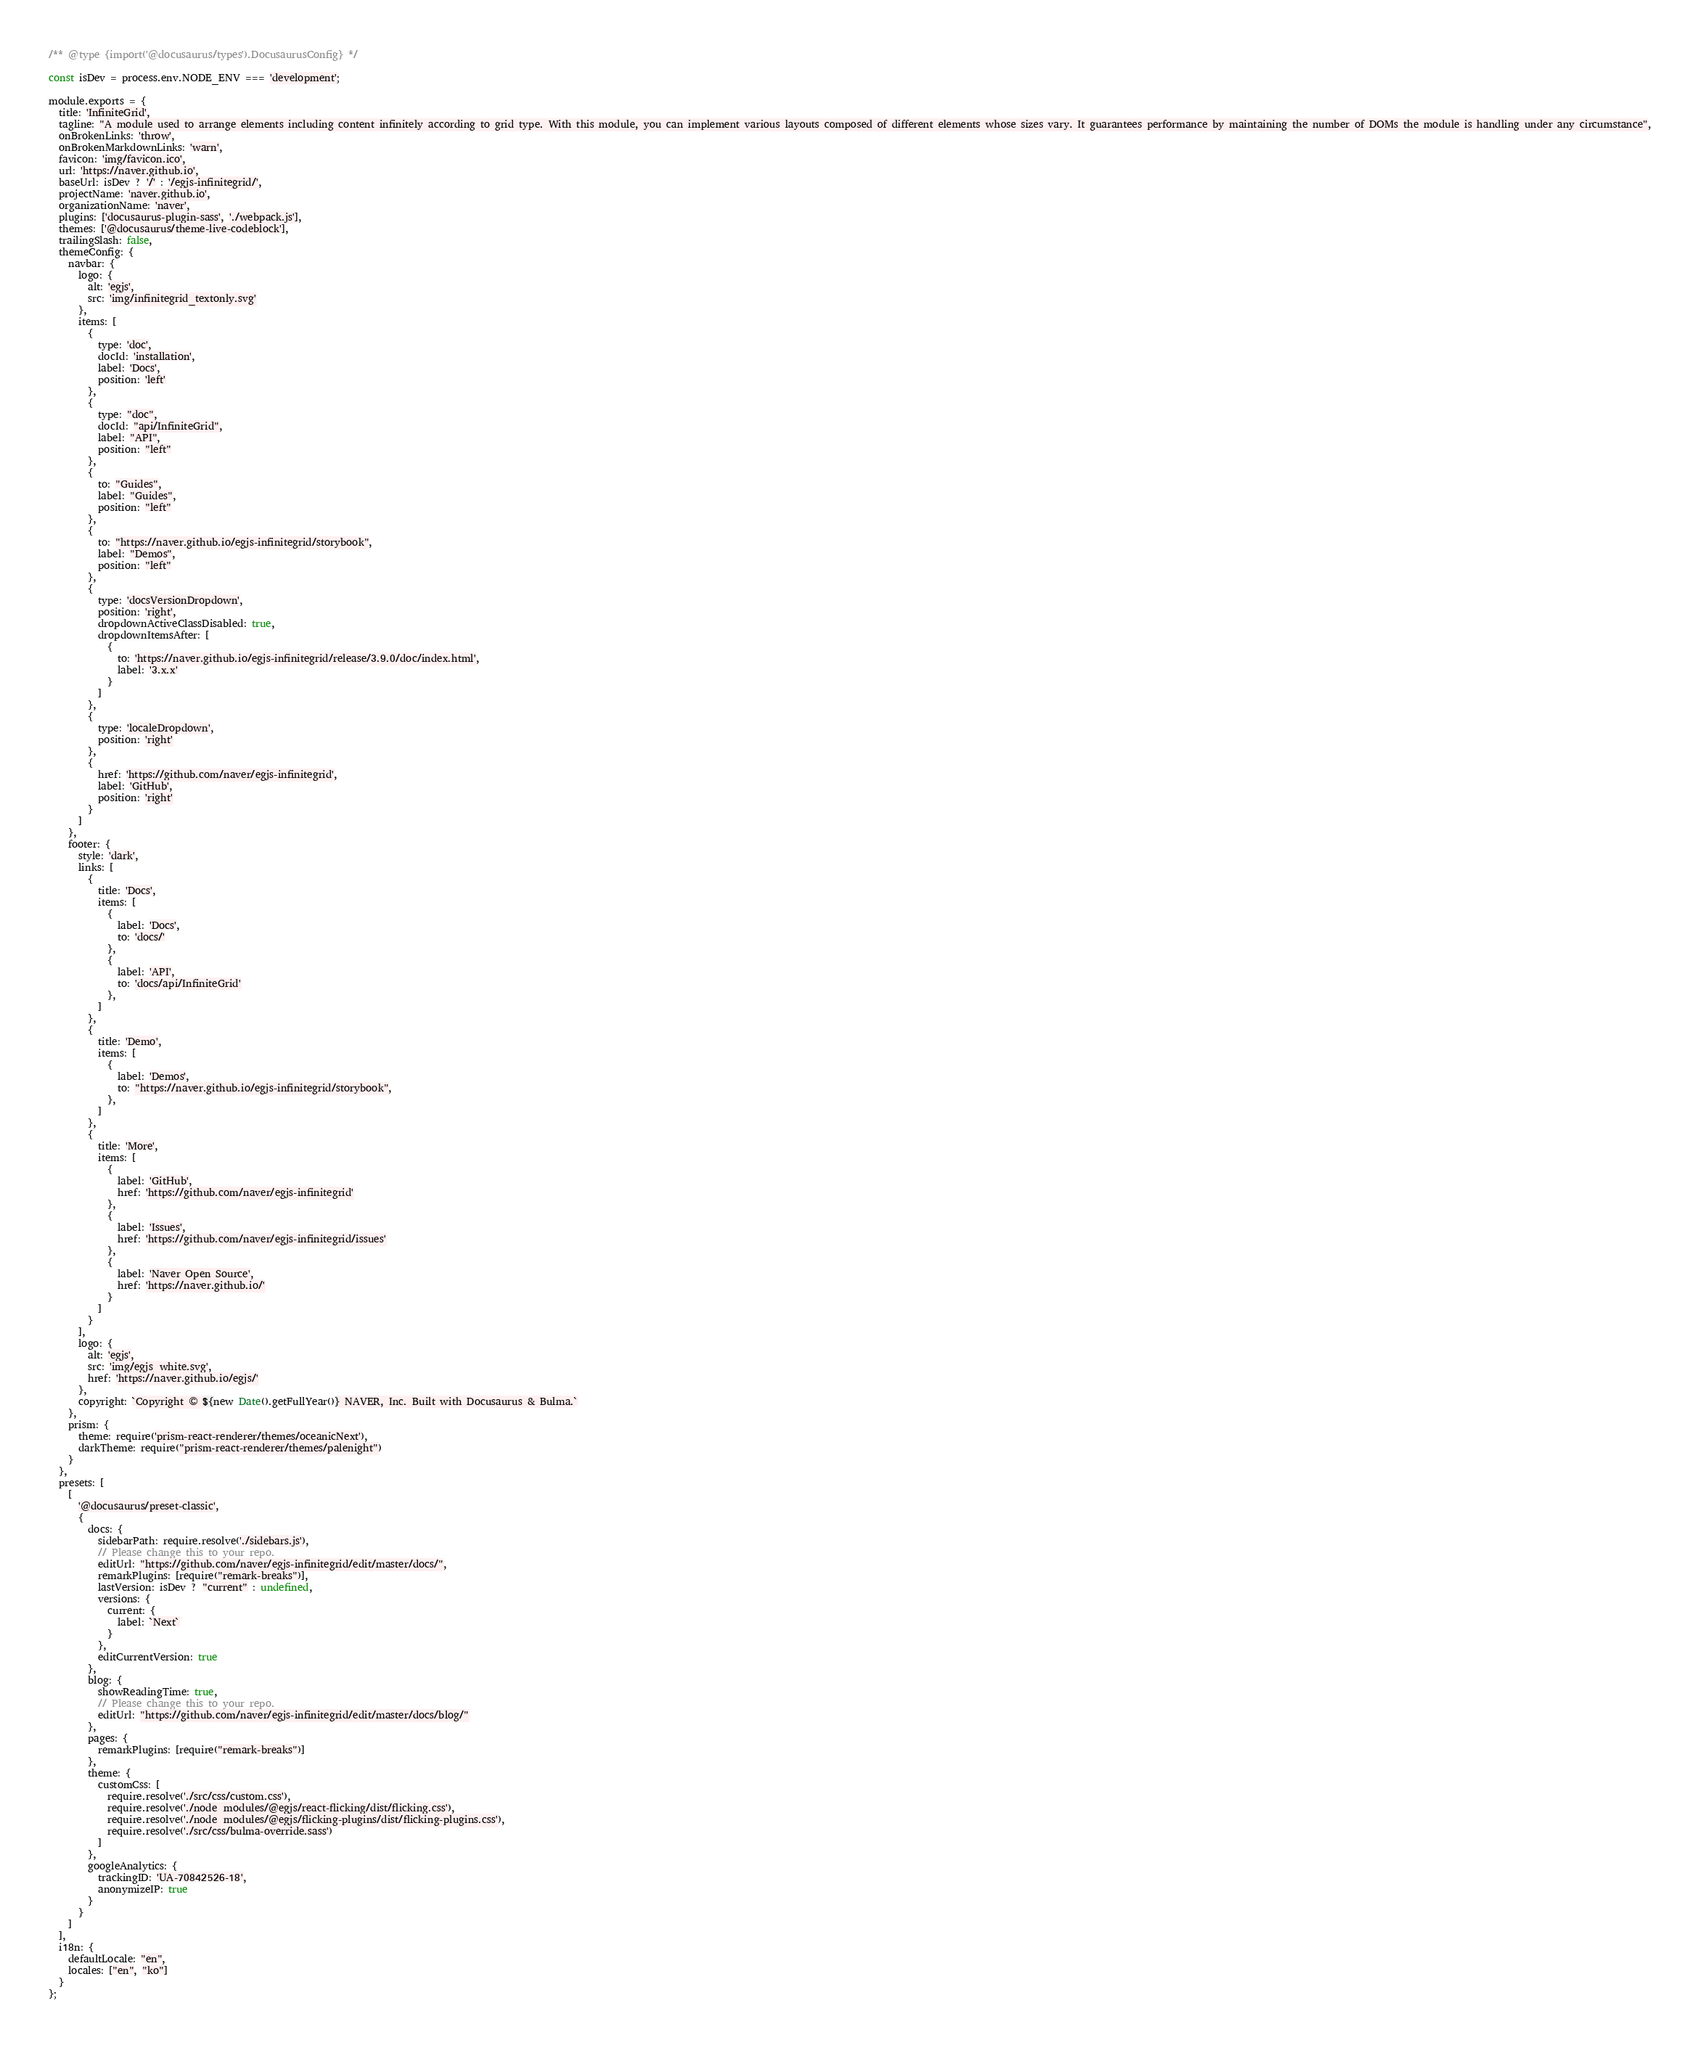Convert code to text. <code><loc_0><loc_0><loc_500><loc_500><_JavaScript_>/** @type {import('@docusaurus/types').DocusaurusConfig} */

const isDev = process.env.NODE_ENV === 'development';

module.exports = {
  title: 'InfiniteGrid',
  tagline: "A module used to arrange elements including content infinitely according to grid type. With this module, you can implement various layouts composed of different elements whose sizes vary. It guarantees performance by maintaining the number of DOMs the module is handling under any circumstance",
  onBrokenLinks: 'throw',
  onBrokenMarkdownLinks: 'warn',
  favicon: 'img/favicon.ico',
  url: 'https://naver.github.io',
  baseUrl: isDev ? '/' : '/egjs-infinitegrid/',
  projectName: 'naver.github.io',
  organizationName: 'naver',
  plugins: ['docusaurus-plugin-sass', './webpack.js'],
  themes: ['@docusaurus/theme-live-codeblock'],
  trailingSlash: false,
  themeConfig: {
    navbar: {
      logo: {
        alt: 'egjs',
        src: 'img/infinitegrid_textonly.svg'
      },
      items: [
        {
          type: 'doc',
          docId: 'installation',
          label: 'Docs',
          position: 'left'
        },
        {
          type: "doc",
          docId: "api/InfiniteGrid",
          label: "API",
          position: "left"
        },
        {
          to: "Guides",
          label: "Guides",
          position: "left"
        },
        {
          to: "https://naver.github.io/egjs-infinitegrid/storybook",
          label: "Demos",
          position: "left"
        },
        {
          type: 'docsVersionDropdown',
          position: 'right',
          dropdownActiveClassDisabled: true,
          dropdownItemsAfter: [
            {
              to: 'https://naver.github.io/egjs-infinitegrid/release/3.9.0/doc/index.html',
              label: '3.x.x'
            }
          ]
        },
        {
          type: 'localeDropdown',
          position: 'right'
        },
        {
          href: 'https://github.com/naver/egjs-infinitegrid',
          label: 'GitHub',
          position: 'right'
        }
      ]
    },
    footer: {
      style: 'dark',
      links: [
        {
          title: 'Docs',
          items: [
            {
              label: 'Docs',
              to: 'docs/'
            },
            {
              label: 'API',
              to: 'docs/api/InfiniteGrid'
            },
          ]
        },
        {
          title: 'Demo',
          items: [
            {
              label: 'Demos',
              to: "https://naver.github.io/egjs-infinitegrid/storybook",
            },
          ]
        },
        {
          title: 'More',
          items: [
            {
              label: 'GitHub',
              href: 'https://github.com/naver/egjs-infinitegrid'
            },
            {
              label: 'Issues',
              href: 'https://github.com/naver/egjs-infinitegrid/issues'
            },
            {
              label: 'Naver Open Source',
              href: 'https://naver.github.io/'
            }
          ]
        }
      ],
      logo: {
        alt: 'egjs',
        src: 'img/egjs_white.svg',
        href: 'https://naver.github.io/egjs/'
      },
      copyright: `Copyright © ${new Date().getFullYear()} NAVER, Inc. Built with Docusaurus & Bulma.`
    },
    prism: {
      theme: require('prism-react-renderer/themes/oceanicNext'),
      darkTheme: require("prism-react-renderer/themes/palenight")
    }
  },
  presets: [
    [
      '@docusaurus/preset-classic',
      {
        docs: {
          sidebarPath: require.resolve('./sidebars.js'),
          // Please change this to your repo.
          editUrl: "https://github.com/naver/egjs-infinitegrid/edit/master/docs/",
          remarkPlugins: [require("remark-breaks")],
          lastVersion: isDev ? "current" : undefined,
          versions: {
            current: {
              label: `Next`
            }
          },
          editCurrentVersion: true
        },
        blog: {
          showReadingTime: true,
          // Please change this to your repo.
          editUrl: "https://github.com/naver/egjs-infinitegrid/edit/master/docs/blog/"
        },
        pages: {
          remarkPlugins: [require("remark-breaks")]
        },
        theme: {
          customCss: [
            require.resolve('./src/css/custom.css'),
            require.resolve('./node_modules/@egjs/react-flicking/dist/flicking.css'),
            require.resolve('./node_modules/@egjs/flicking-plugins/dist/flicking-plugins.css'),
            require.resolve('./src/css/bulma-override.sass')
          ]
        },
        googleAnalytics: {
          trackingID: 'UA-70842526-18',
          anonymizeIP: true
        }
      }
    ]
  ],
  i18n: {
    defaultLocale: "en",
    locales: ["en", "ko"]
  }
};
</code> 